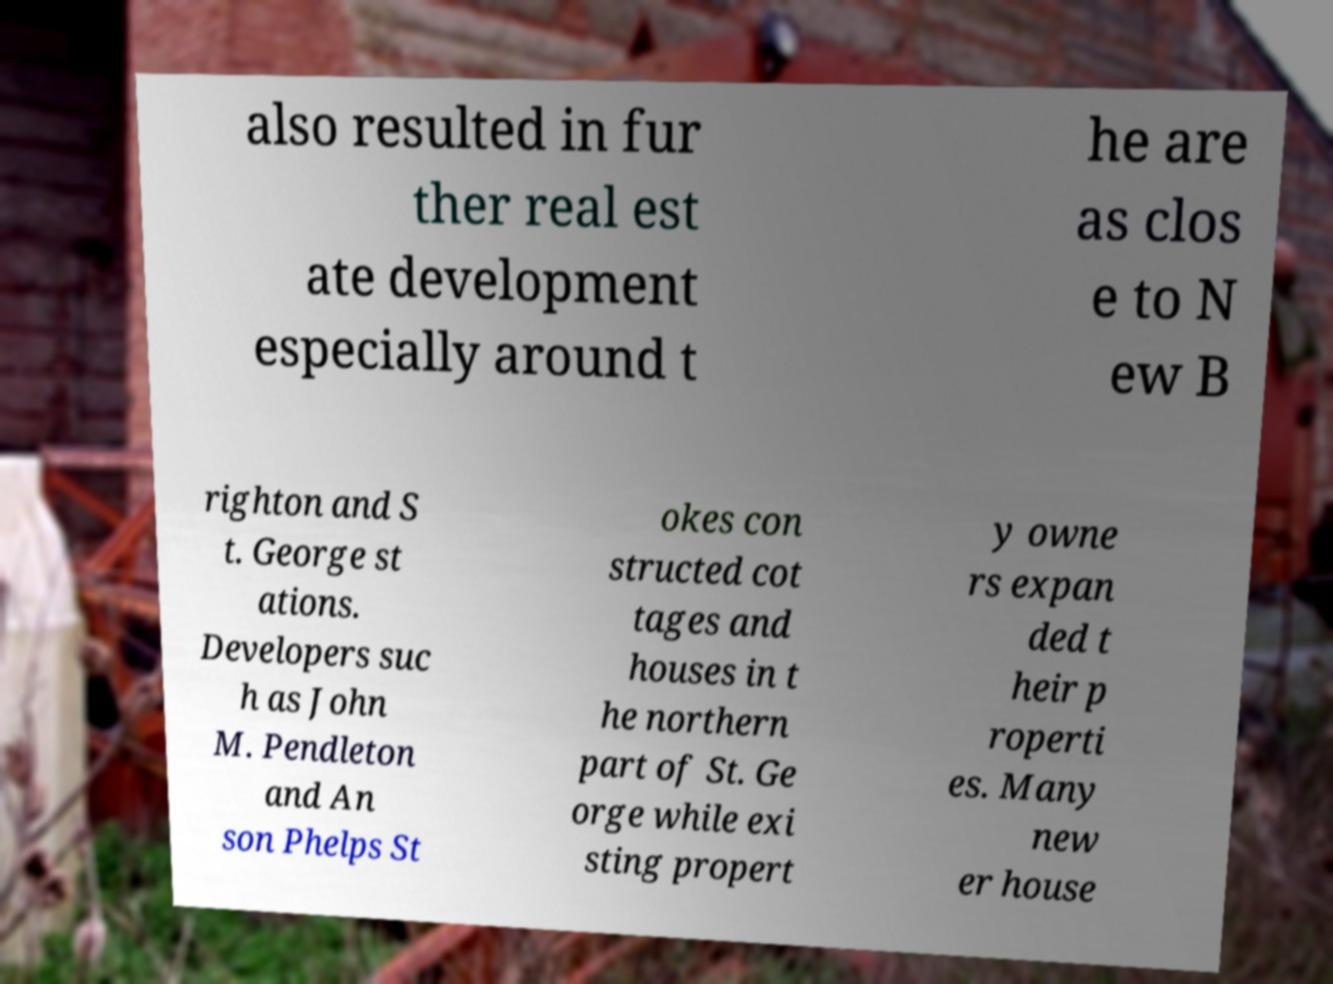For documentation purposes, I need the text within this image transcribed. Could you provide that? also resulted in fur ther real est ate development especially around t he are as clos e to N ew B righton and S t. George st ations. Developers suc h as John M. Pendleton and An son Phelps St okes con structed cot tages and houses in t he northern part of St. Ge orge while exi sting propert y owne rs expan ded t heir p roperti es. Many new er house 